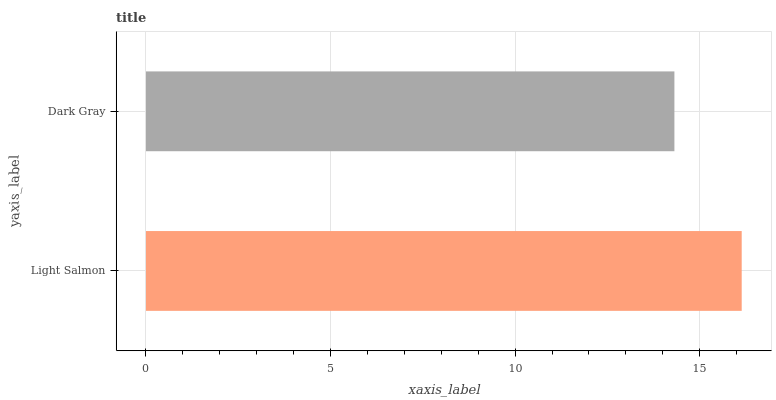Is Dark Gray the minimum?
Answer yes or no. Yes. Is Light Salmon the maximum?
Answer yes or no. Yes. Is Dark Gray the maximum?
Answer yes or no. No. Is Light Salmon greater than Dark Gray?
Answer yes or no. Yes. Is Dark Gray less than Light Salmon?
Answer yes or no. Yes. Is Dark Gray greater than Light Salmon?
Answer yes or no. No. Is Light Salmon less than Dark Gray?
Answer yes or no. No. Is Light Salmon the high median?
Answer yes or no. Yes. Is Dark Gray the low median?
Answer yes or no. Yes. Is Dark Gray the high median?
Answer yes or no. No. Is Light Salmon the low median?
Answer yes or no. No. 